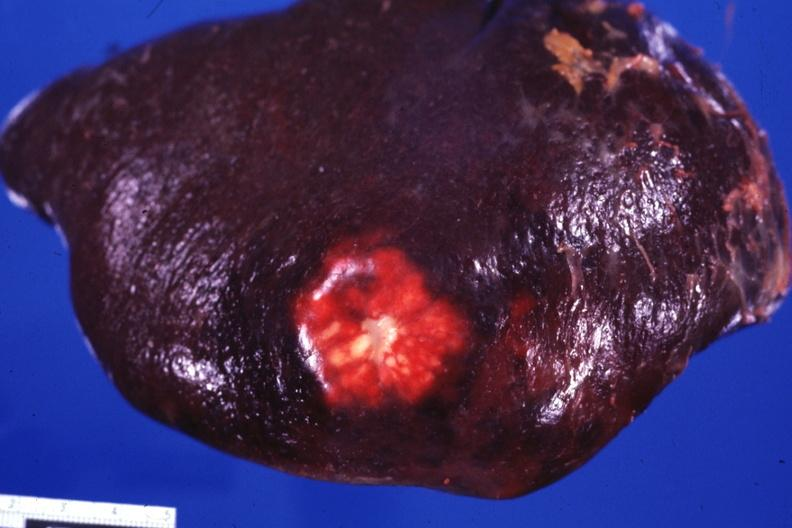s pus in test tube present?
Answer the question using a single word or phrase. No 